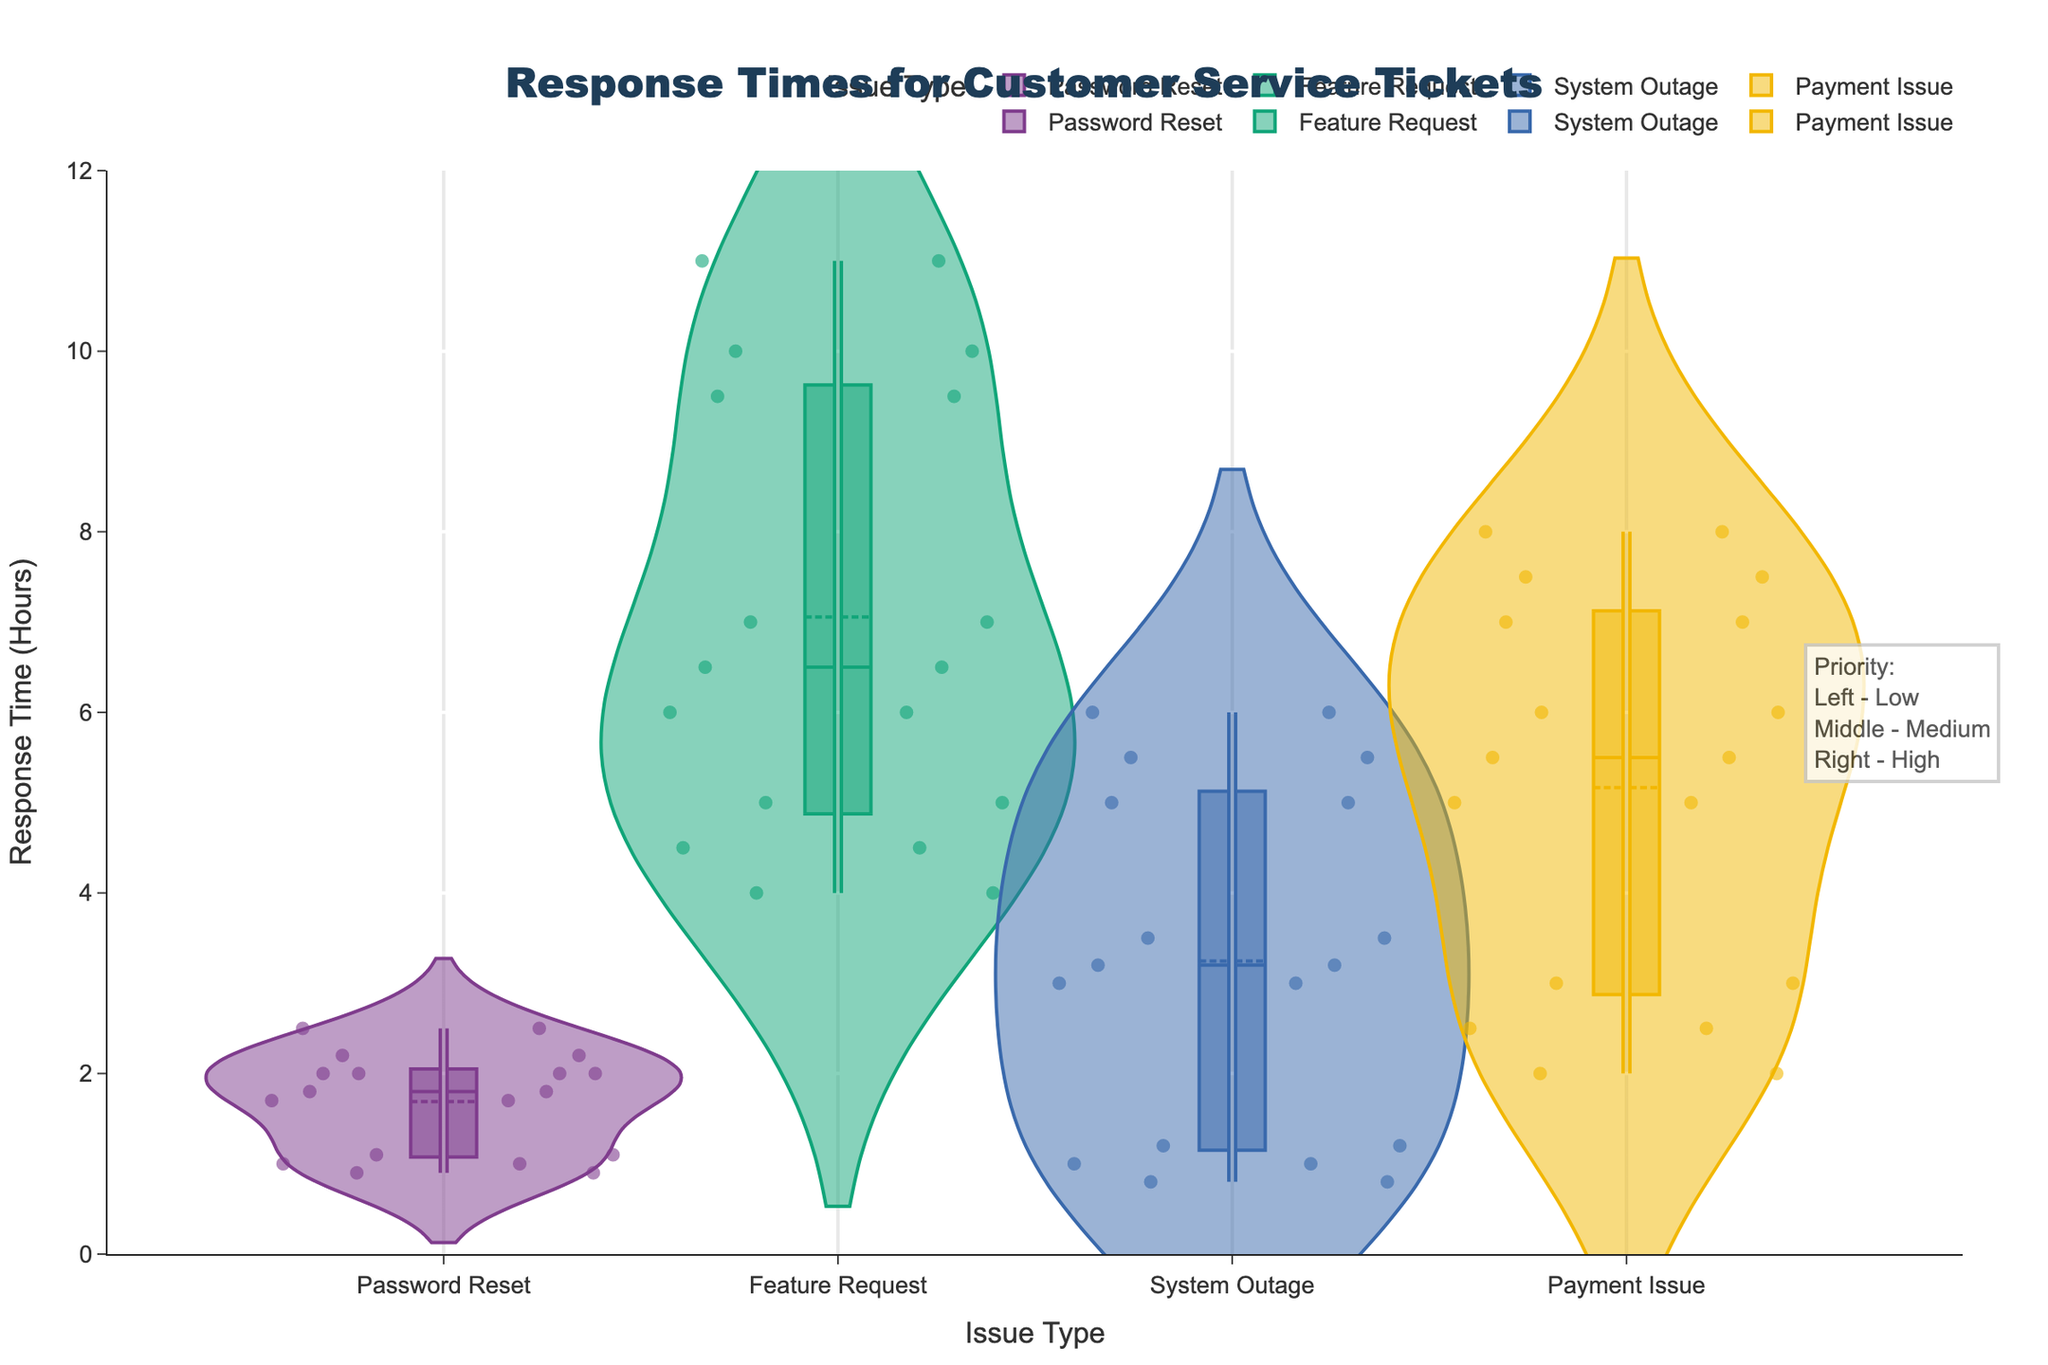How many different issue types are represented in the chart? Count the unique categories on the x-axis labels representing different issue types.
Answer: 4 Which issue type generally has the shortest response times? Compare the range of the distributions for each issue type. The one with lower values generally represents shorter response times.
Answer: Password Reset What is the response time range for high priority 'Feature Request' tickets? Observe the positive side of the split violin for 'Feature Request' and identify the lower and upper bounds of the high-priority distribution.
Answer: 4 to 5 hours Which priority level tends to have the lowest response time for 'System Outage' tickets? Compare the lowest points within the 'System Outage' category across different priority levels.
Answer: High What is the difference in median response times between medium and high priority 'Payment Issue' tickets? Locate the median lines for both medium and high priorities in 'Payment Issue' and find the numerical difference.
Answer: 3 hours Which issue type shows the greatest variation in response times for high priority tickets? Compare the spread of the high priority distributions across different issue types. Larger spreads indicate greater variation.
Answer: Feature Request What is the median response time for low priority 'Password Reset' tickets? Identify the median line for the low priority distribution within the 'Password Reset' category.
Answer: 2.2 hours How does the response time for low priority 'Payment Issue' compare to medium priority 'Feature Request'? Compare the locations of the central tendency (mean or median) for low priority 'Payment Issue' and medium priority 'Feature Request'.
Answer: Payment Issue is longer What can be said about the general trend of response times as the priority level increases? Observe the central tendencies (medians and means) for each issue type across different priority levels. Typically, higher priorities should have lower response times.
Answer: Response times decrease Which issue type generally has higher response times compared to others? Compare the range of distributions for each issue type to identify which one spans higher values.
Answer: Feature Request 